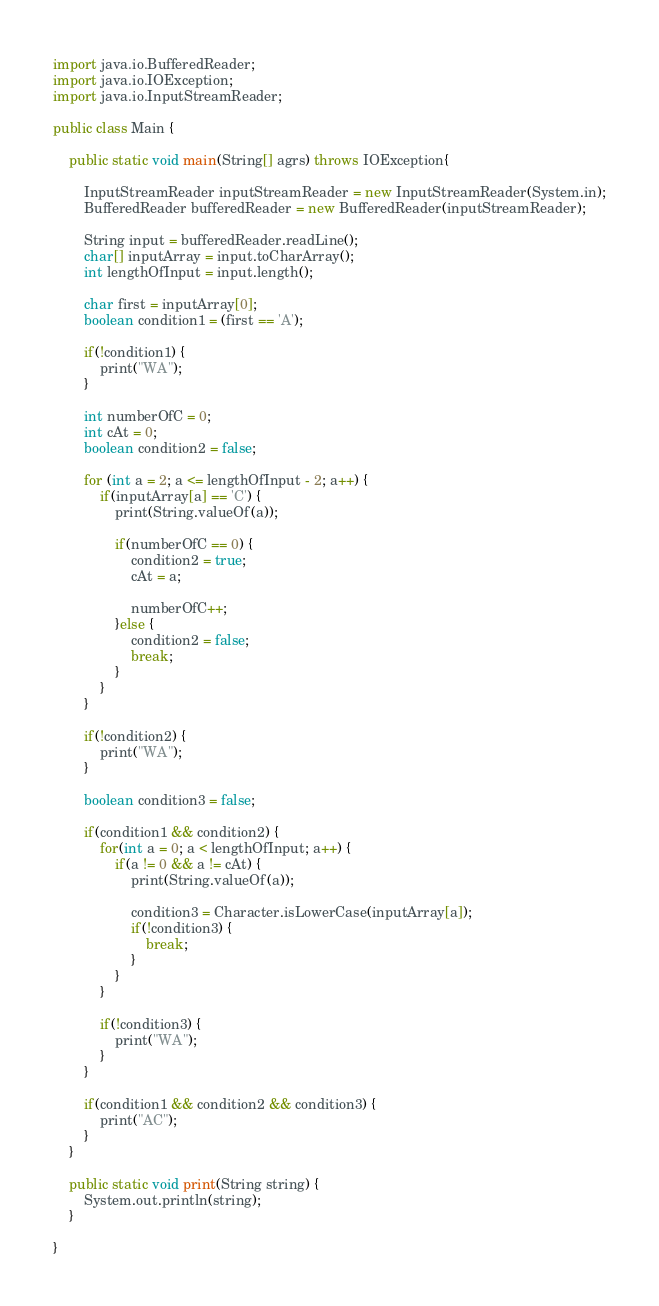Convert code to text. <code><loc_0><loc_0><loc_500><loc_500><_Java_>import java.io.BufferedReader;
import java.io.IOException;
import java.io.InputStreamReader;

public class Main {
	
	public static void main(String[] agrs) throws IOException{
		
		InputStreamReader inputStreamReader = new InputStreamReader(System.in);
		BufferedReader bufferedReader = new BufferedReader(inputStreamReader);
		
		String input = bufferedReader.readLine();
		char[] inputArray = input.toCharArray();
		int lengthOfInput = input.length();
				
		char first = inputArray[0];
		boolean condition1 = (first == 'A');
		
		if(!condition1) {
			print("WA");
		}
		
		int numberOfC = 0;
		int cAt = 0;
		boolean condition2 = false;
		
		for (int a = 2; a <= lengthOfInput - 2; a++) {
			if(inputArray[a] == 'C') {
				print(String.valueOf(a));
				
				if(numberOfC == 0) {
					condition2 = true;
					cAt = a;
					
					numberOfC++;
				}else {
					condition2 = false;
					break;
				}
			}
		}
		
		if(!condition2) {
			print("WA");
		}
		
		boolean condition3 = false;
		
		if(condition1 && condition2) {
			for(int a = 0; a < lengthOfInput; a++) {
				if(a != 0 && a != cAt) {
					print(String.valueOf(a));
					
					condition3 = Character.isLowerCase(inputArray[a]);
					if(!condition3) {
						break;
					}
				}
			}
			
			if(!condition3) {
				print("WA");
			}
		}
		
		if(condition1 && condition2 && condition3) {
			print("AC");
		}
	}
	
	public static void print(String string) {
		System.out.println(string);
	}
	
}
</code> 